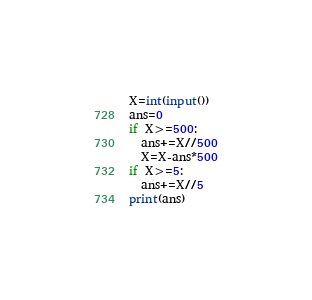<code> <loc_0><loc_0><loc_500><loc_500><_Python_>X=int(input())
ans=0
if X>=500:
  ans+=X//500
  X=X-ans*500
if X>=5:
  ans+=X//5
print(ans)</code> 